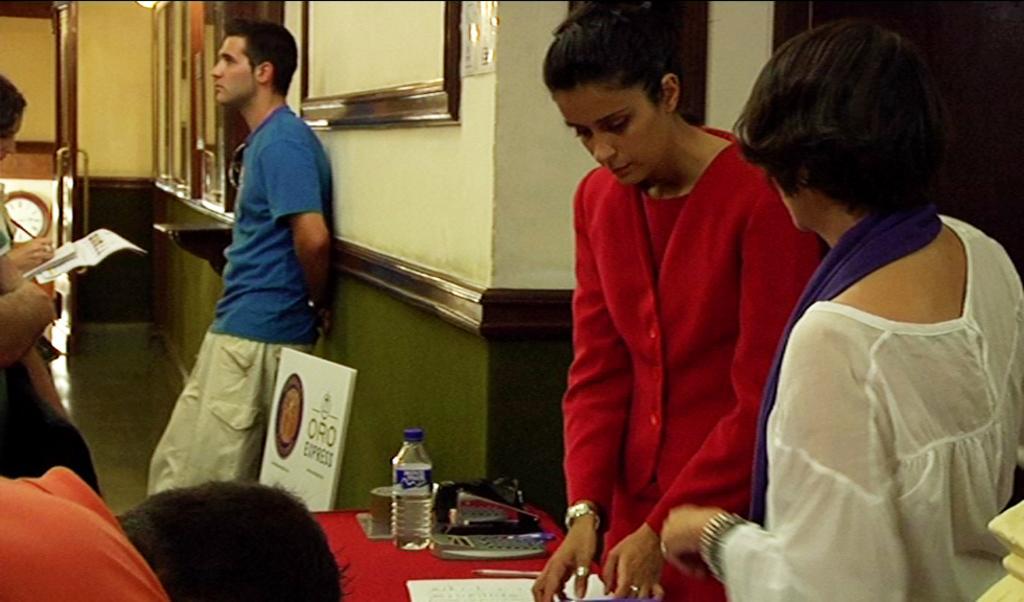Could you give a brief overview of what you see in this image? In this image, we can see people standing and one of them is holding a pen and some papers. In the background, there is a light, frame, board, door and a wall and we can see a bottle, paper, pencil and some objects are on the table. At the bottom, there is floor. 